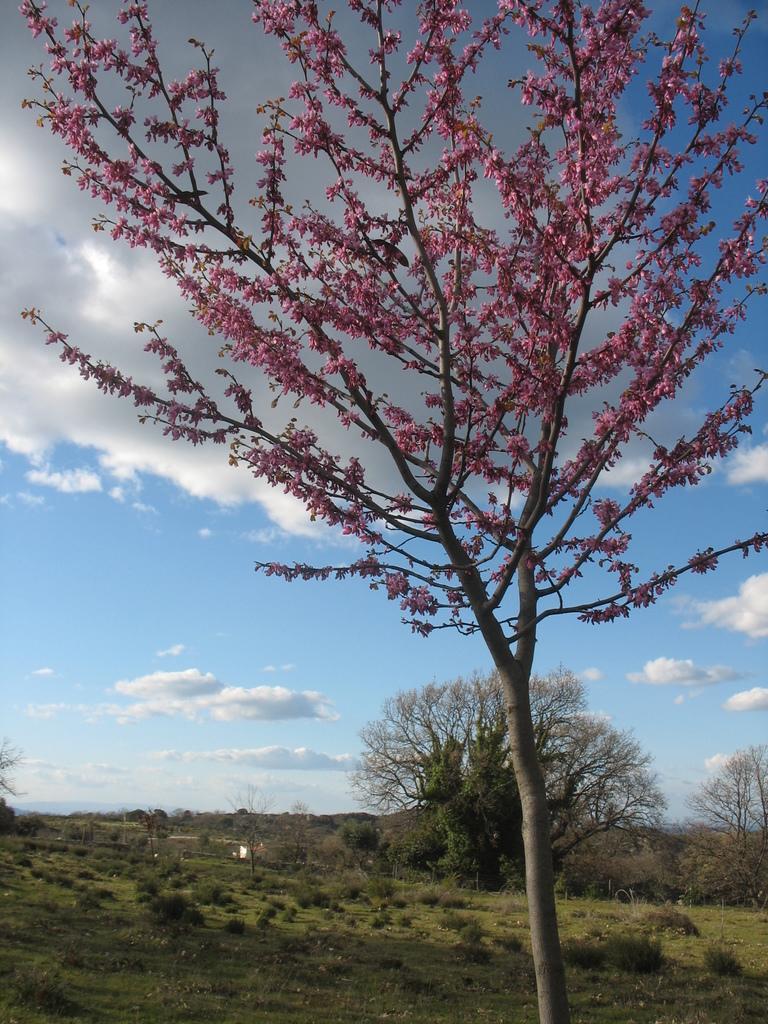In one or two sentences, can you explain what this image depicts? In the foreground of the image we can see the flowers on the branches of a tree. In the background, we can see a group of trees and the cloudy sky. 